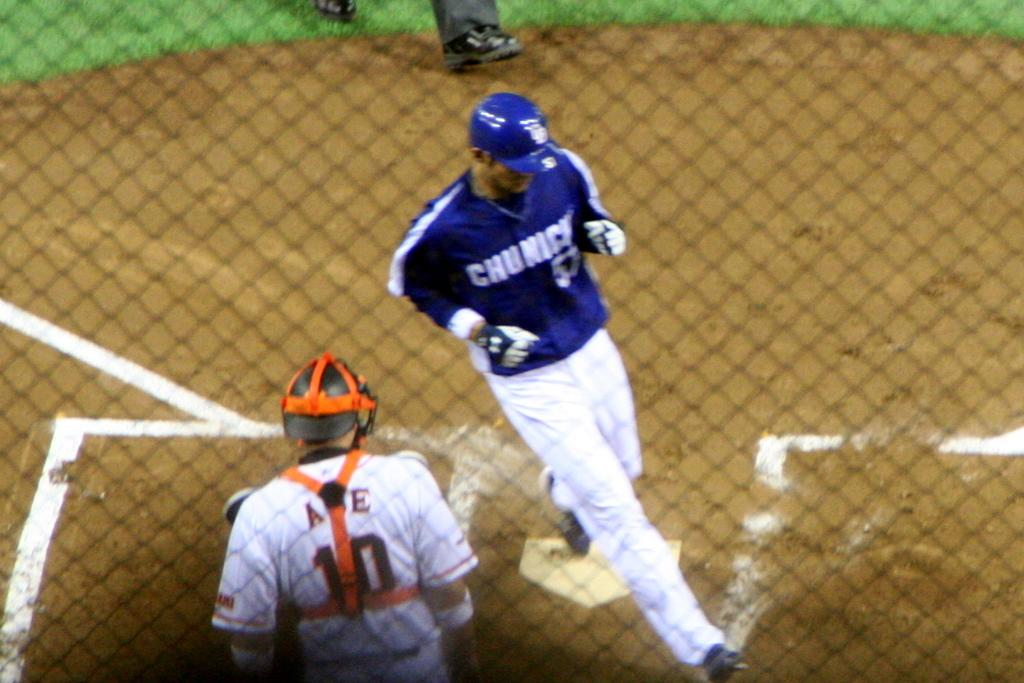<image>
Relay a brief, clear account of the picture shown. Catcher number 10 watches as a player crosses home plate. 